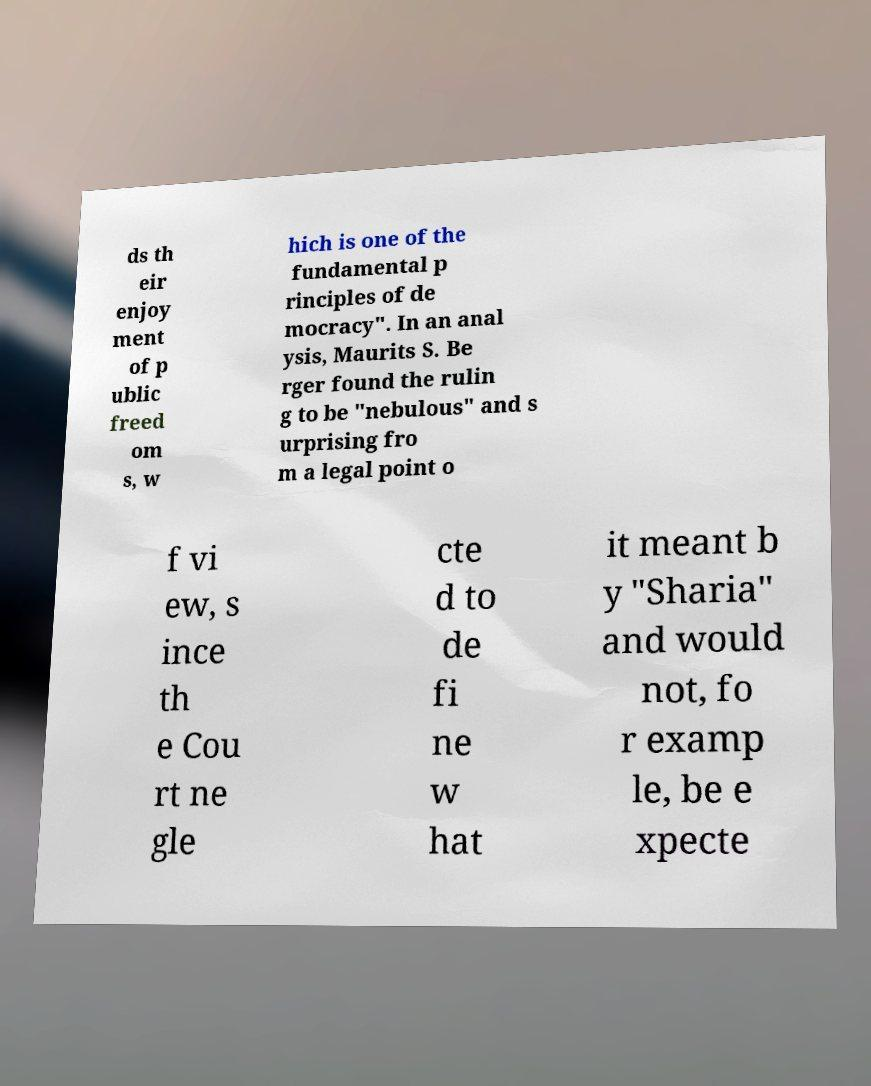Could you assist in decoding the text presented in this image and type it out clearly? ds th eir enjoy ment of p ublic freed om s, w hich is one of the fundamental p rinciples of de mocracy". In an anal ysis, Maurits S. Be rger found the rulin g to be "nebulous" and s urprising fro m a legal point o f vi ew, s ince th e Cou rt ne gle cte d to de fi ne w hat it meant b y "Sharia" and would not, fo r examp le, be e xpecte 